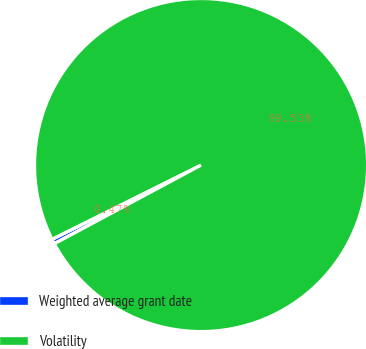Convert chart to OTSL. <chart><loc_0><loc_0><loc_500><loc_500><pie_chart><fcel>Weighted average grant date<fcel>Volatility<nl><fcel>0.47%<fcel>99.53%<nl></chart> 